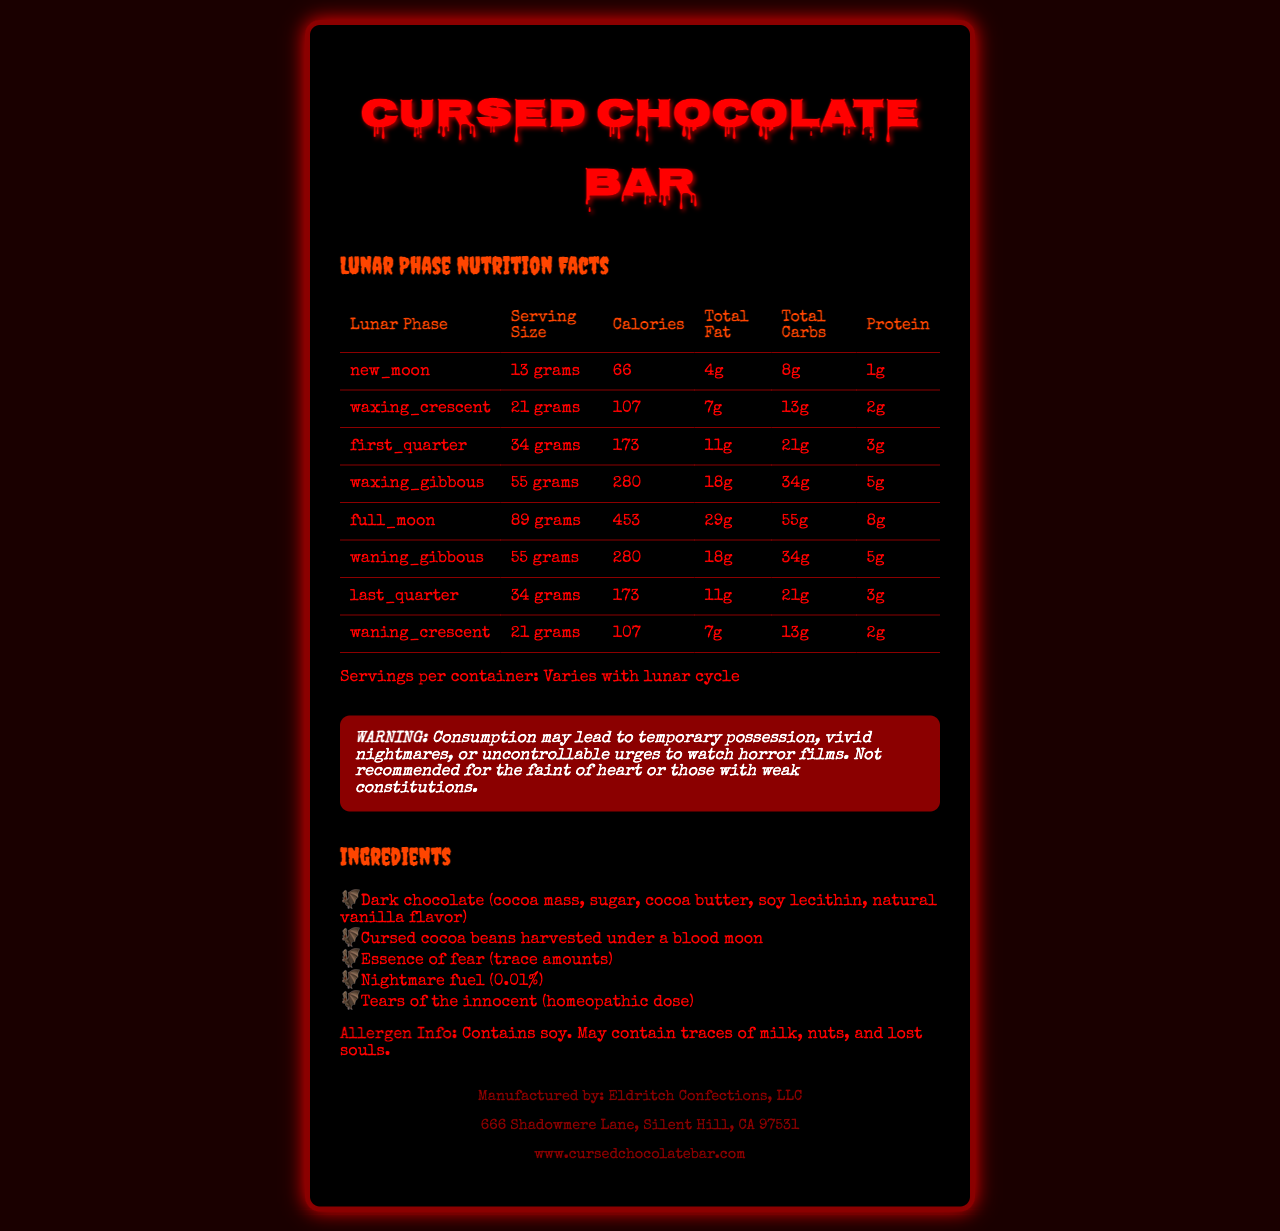what is the serving size of the Cursed Chocolate Bar during a full moon? The serving size for a full moon is listed as 89 grams in the document.
Answer: 89 grams how many calories are in a waxing crescent phase serving? According to the table in the document, the calories for a waxing crescent phase serving are 107.
Answer: 107 what is the amount of trans fat in the Cursed Chocolate Bar? The document states that there are 0 grams of trans fat in the Cursed Chocolate Bar.
Answer: 0 grams how much calcium is in a serving of the Cursed Chocolate Bar? The document lists the amount of calcium per serving as 13 mg.
Answer: 13 mg what are the ingredients of the Cursed Chocolate Bar? The ingredient list includes Dark chocolate (cocoa mass, sugar, cocoa butter, soy lecithin, natural vanilla flavor), Cursed cocoa beans harvested under a blood moon, Essence of fear (trace amounts), Nightmare fuel (0.01%), and Tears of the innocent (homeopathic dose).
Answer: Dark chocolate (cocoa mass, sugar, cocoa butter, soy lecithin, natural vanilla flavor), Cursed cocoa beans harvested under a blood moon, Essence of fear (trace amounts), Nightmare fuel (0.01%), Tears of the innocent (homeopathic dose) how many grams of total fat are in a first quarter phase serving? The total fat for a first quarter phase serving is 11 grams as per the document.
Answer: 11 grams what lunar phase has the highest number of calories per serving? The full moon phase has the highest calorie count at 453 calories per serving.
Answer: Full moon which of the following ingredients is NOT listed in the Cursed Chocolate Bar? A. Dark chocolate B. Essence of joy C. Nightmare fuel D. Cursed cocoa beans Essence of joy is not listed as an ingredient in the Cursed Chocolate Bar. The others are included in the ingredient list.
Answer: B which lunar phase has the least amount of total carbohydrates? I. New moon II. Waxing crescent III. Full moon IV. Waning crescent The new moon phase has the least total carbohydrates with 8 grams per serving.
Answer: I is there any cholesterol in the Cursed Chocolate Bar? The document clearly states that the chocolate bar contains 0 mg of cholesterol.
Answer: No summarize the main idea of the document The main idea of the document is to present the nutritional facts of the Cursed Chocolate Bar, highlighting its unique serving sizes that vary according to lunar phases, and to provide essential information on its ingredients, allergens, and other relevant warnings.
Answer: The document provides detailed nutritional information for the Cursed Chocolate Bar, with unique serving sizes based on the lunar phases. It includes information on calories, total fat, total carbohydrates, protein, and other nutritional elements for each phase, as well as a list of ingredients, allergen information, warnings, and manufacturer details. how many servings per container does the Cursed Chocolate Bar have? The document specifies that the number of servings per container varies with the lunar cycle, so it cannot be determined exactly.
Answer: Cannot be determined 